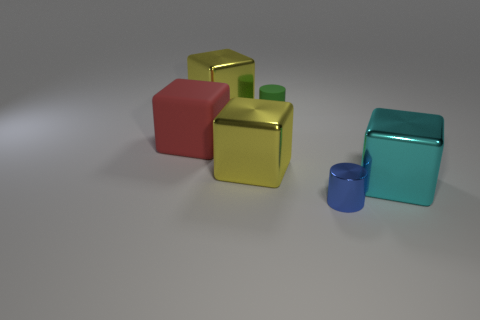Subtract all brown balls. How many yellow cubes are left? 2 Subtract all matte blocks. How many blocks are left? 3 Subtract all red blocks. How many blocks are left? 3 Add 4 large yellow shiny balls. How many objects exist? 10 Subtract all gray blocks. Subtract all green balls. How many blocks are left? 4 Subtract all cubes. How many objects are left? 2 Add 1 large red metallic cylinders. How many large red metallic cylinders exist? 1 Subtract 0 yellow cylinders. How many objects are left? 6 Subtract all cyan objects. Subtract all small rubber cylinders. How many objects are left? 4 Add 4 cyan things. How many cyan things are left? 5 